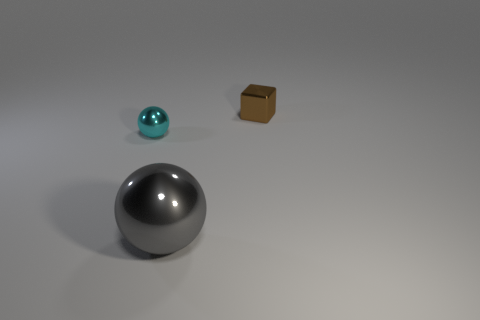Is there any other thing that is the same size as the gray metallic ball?
Make the answer very short. No. There is a shiny object that is to the right of the small sphere and in front of the small brown metallic cube; what is its color?
Provide a short and direct response. Gray. Are there any cyan things that have the same shape as the gray metal object?
Ensure brevity in your answer.  Yes. There is a small shiny thing that is right of the gray ball; are there any metal things left of it?
Offer a very short reply. Yes. What number of objects are things to the right of the small cyan metal sphere or metallic things that are behind the small cyan metal object?
Your answer should be very brief. 2. What number of things are either gray rubber things or objects left of the small brown metallic object?
Your answer should be very brief. 2. What is the size of the brown shiny block behind the big gray object that is in front of the shiny object that is to the left of the gray metal ball?
Ensure brevity in your answer.  Small. What is the material of the brown cube that is the same size as the cyan thing?
Offer a very short reply. Metal. Is there a yellow matte block that has the same size as the cyan shiny sphere?
Your answer should be compact. No. There is a metallic thing behind the cyan metallic sphere; is it the same size as the big object?
Give a very brief answer. No. 